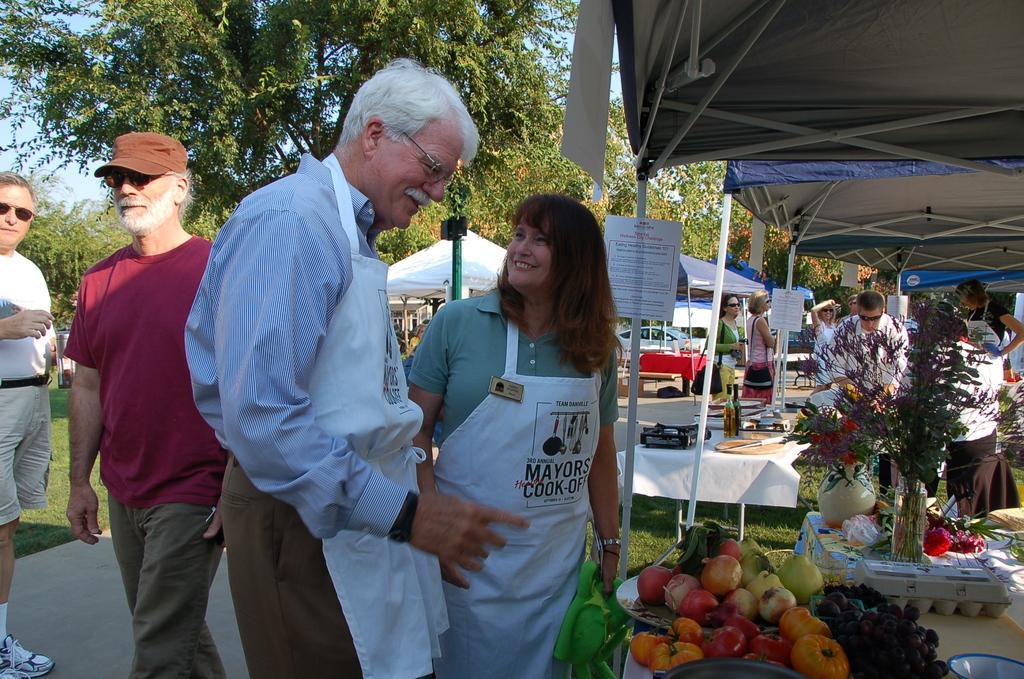Please provide a concise description of this image. In this picture I can see fruits on the plates and I can see few are standing and a human walking. I can see tents and few posters with some text and I can see a flower vase, egg box and few flowers on the table and in the back I can see bottles and few items on the another table. I can see trees and a blue cloudy sky and I can see grass on the ground. 